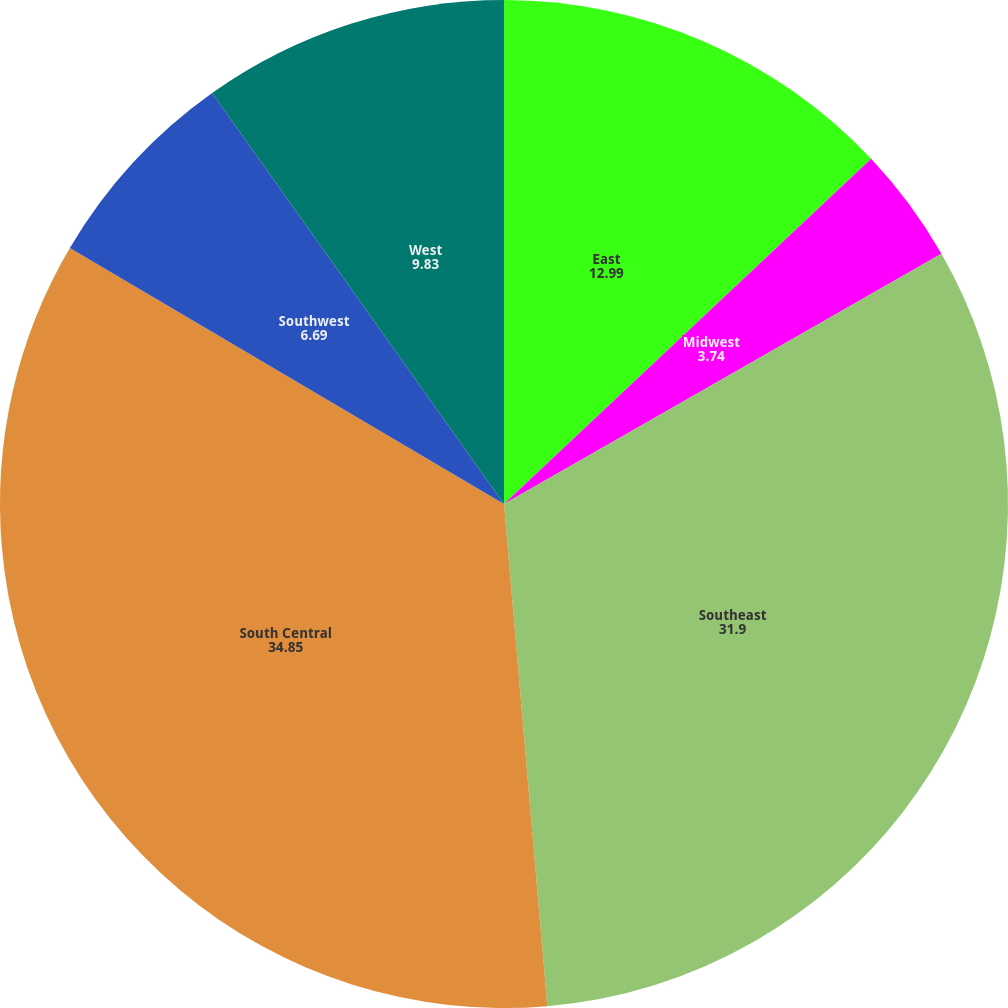Convert chart to OTSL. <chart><loc_0><loc_0><loc_500><loc_500><pie_chart><fcel>East<fcel>Midwest<fcel>Southeast<fcel>South Central<fcel>Southwest<fcel>West<nl><fcel>12.99%<fcel>3.74%<fcel>31.9%<fcel>34.85%<fcel>6.69%<fcel>9.83%<nl></chart> 